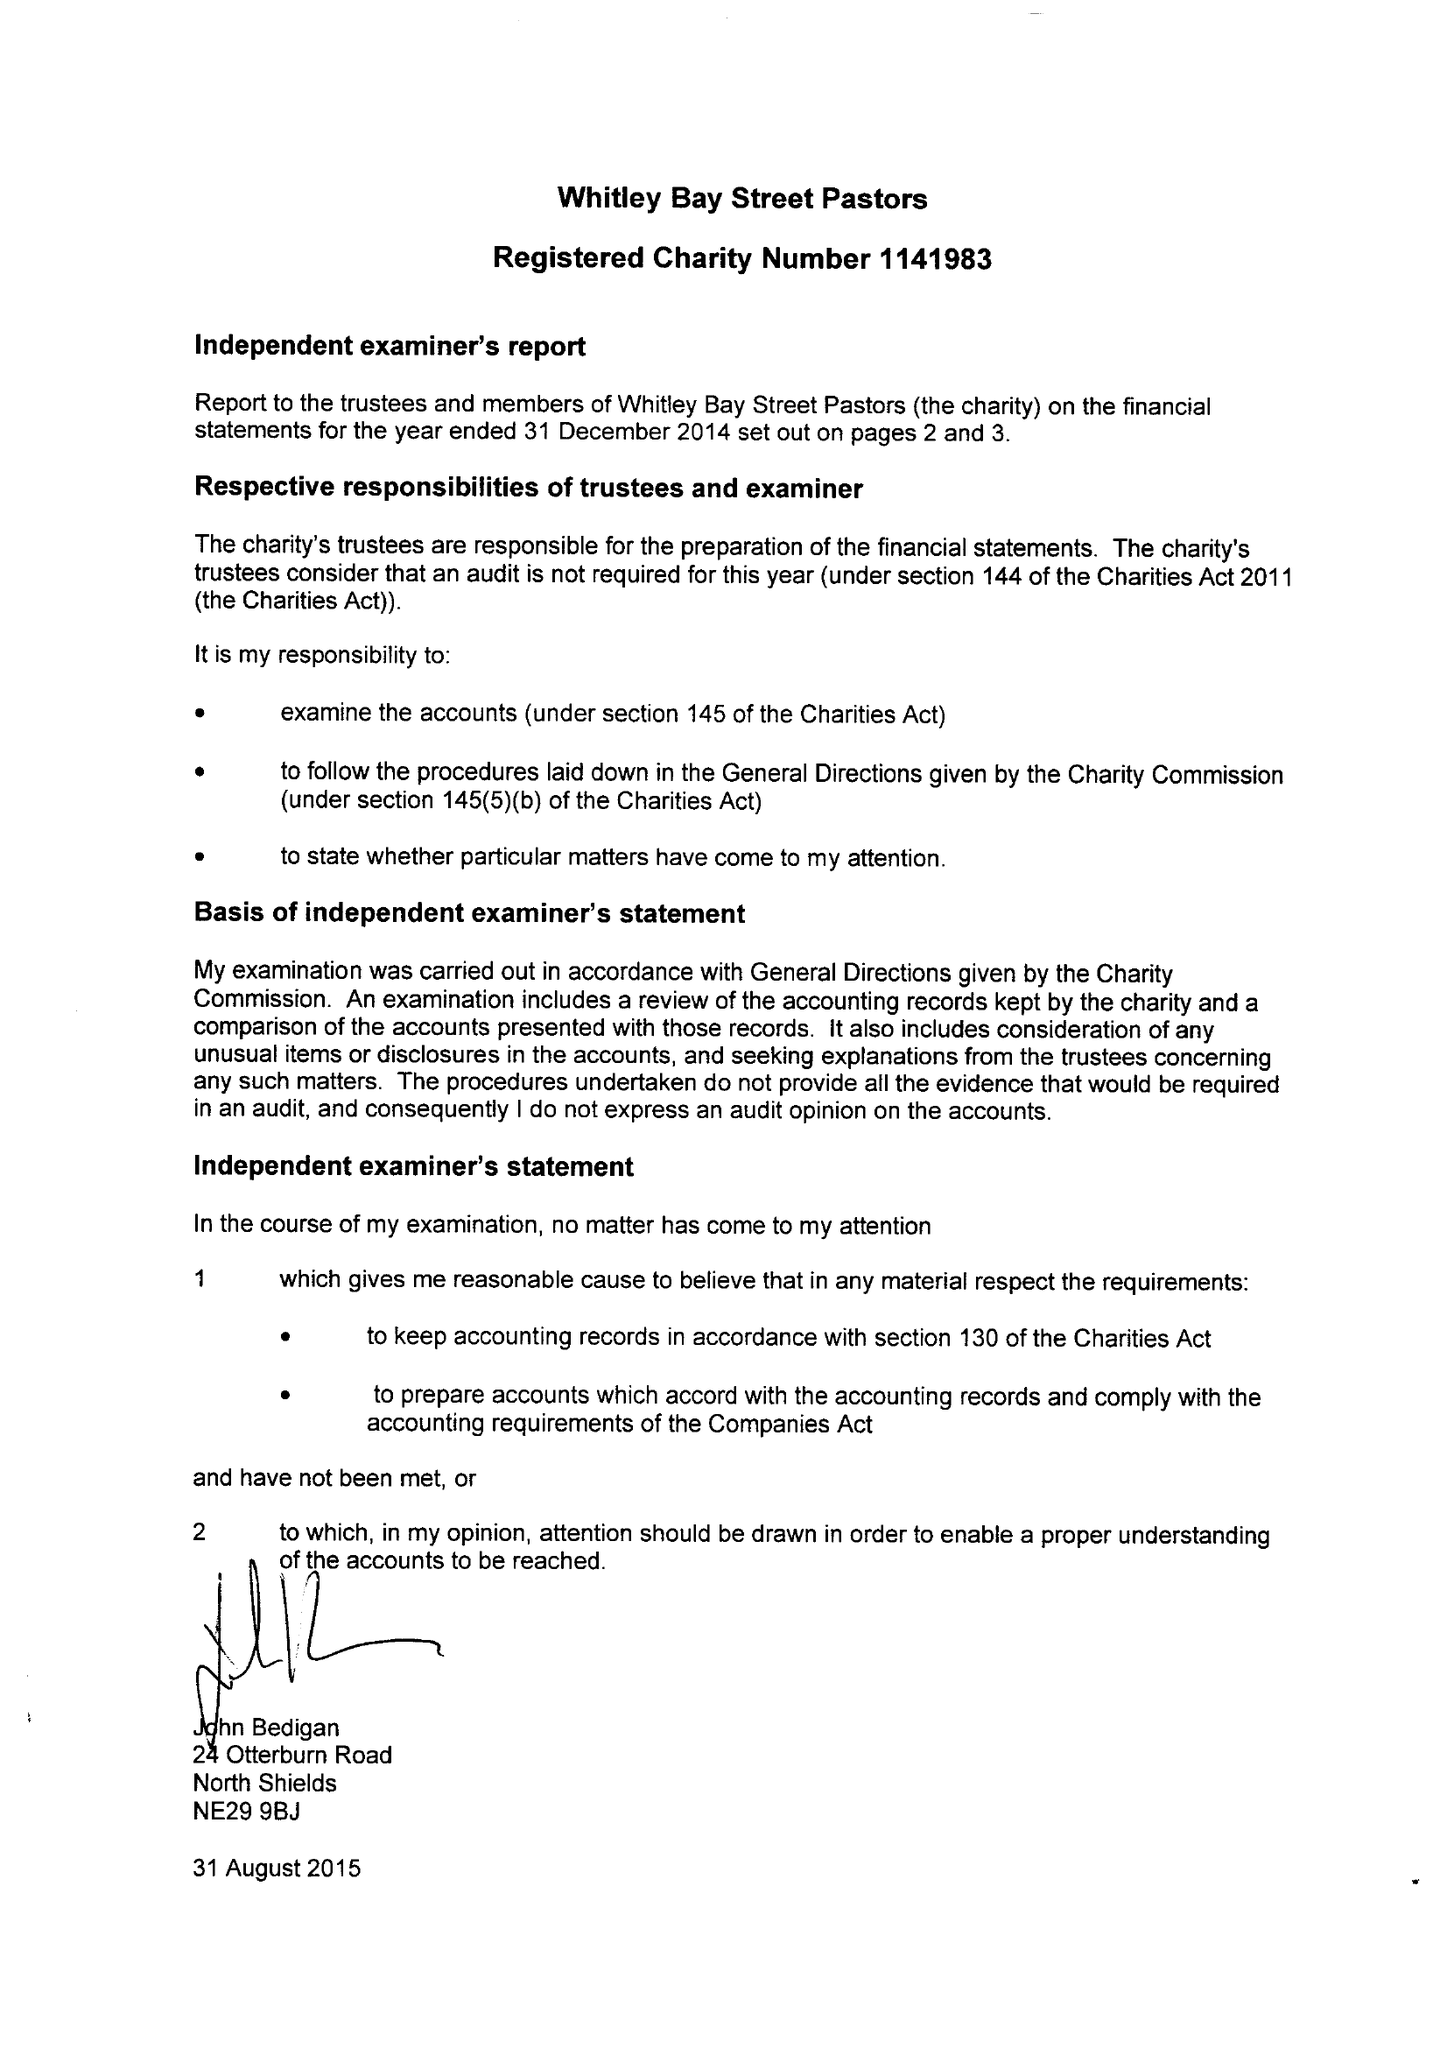What is the value for the charity_number?
Answer the question using a single word or phrase. 1141983 